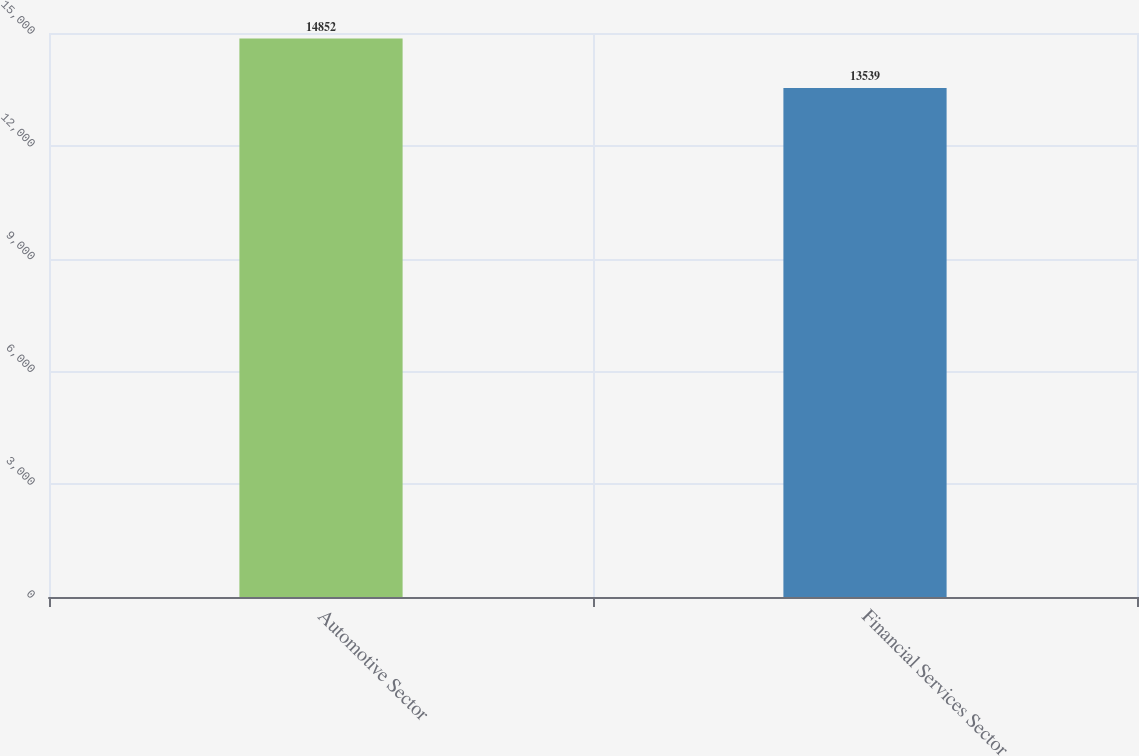Convert chart. <chart><loc_0><loc_0><loc_500><loc_500><bar_chart><fcel>Automotive Sector<fcel>Financial Services Sector<nl><fcel>14852<fcel>13539<nl></chart> 